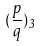Convert formula to latex. <formula><loc_0><loc_0><loc_500><loc_500>( \frac { p } { q } ) _ { 3 }</formula> 